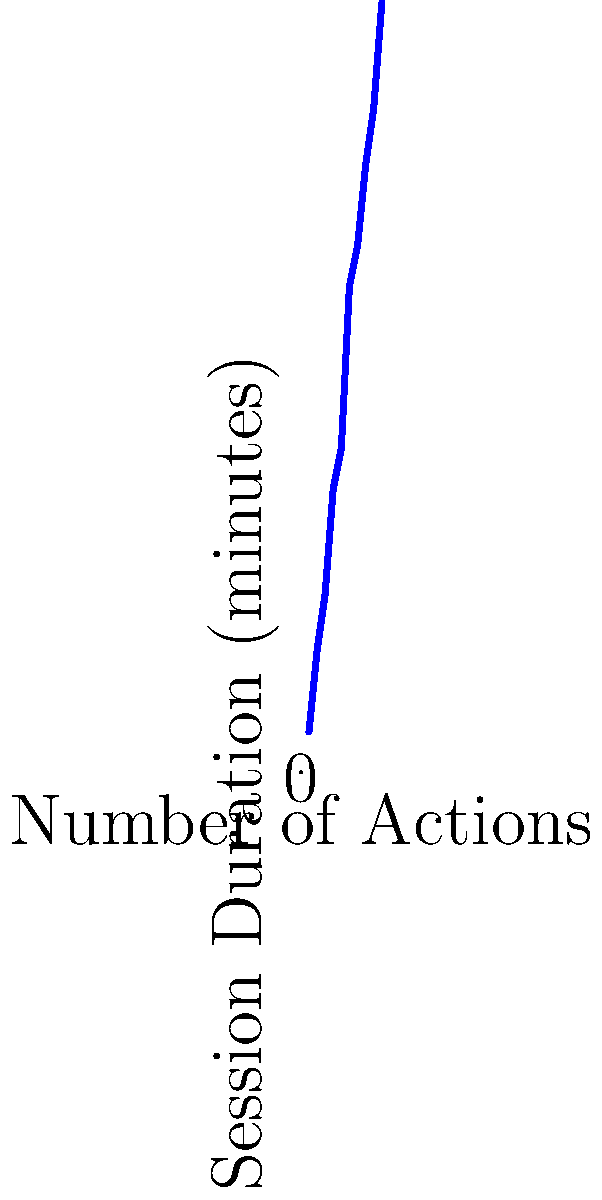Based on the scatter plot showing user session duration versus number of actions taken, what can be inferred about the relationship between these two variables? To interpret this scatter plot, we need to follow these steps:

1. Observe the overall trend: As we move from left to right (increasing number of actions), we see that the points generally move upward (increasing session duration).

2. Assess the strength of the relationship: The points form a clear upward trend with relatively little scatter around an imaginary line of best fit.

3. Identify the type of relationship: The trend appears to be roughly linear, with a positive slope.

4. Look for any outliers or clusters: There don't appear to be any significant outliers or distinct clusters in this data set.

5. Consider the context: For a data analyst looking at user behavior, this plot suggests that users who perform more actions tend to have longer session durations.

6. Quantify the relationship: While we can't calculate an exact correlation coefficient from the plot alone, the strong, positive, linear relationship suggests a high positive correlation between number of actions and session duration.

Given these observations, we can infer that there is a strong positive correlation between the number of actions a user takes and their session duration. This suggests that users who are more actively engaged (taking more actions) tend to spend more time on the platform.
Answer: Strong positive correlation between number of actions and session duration 